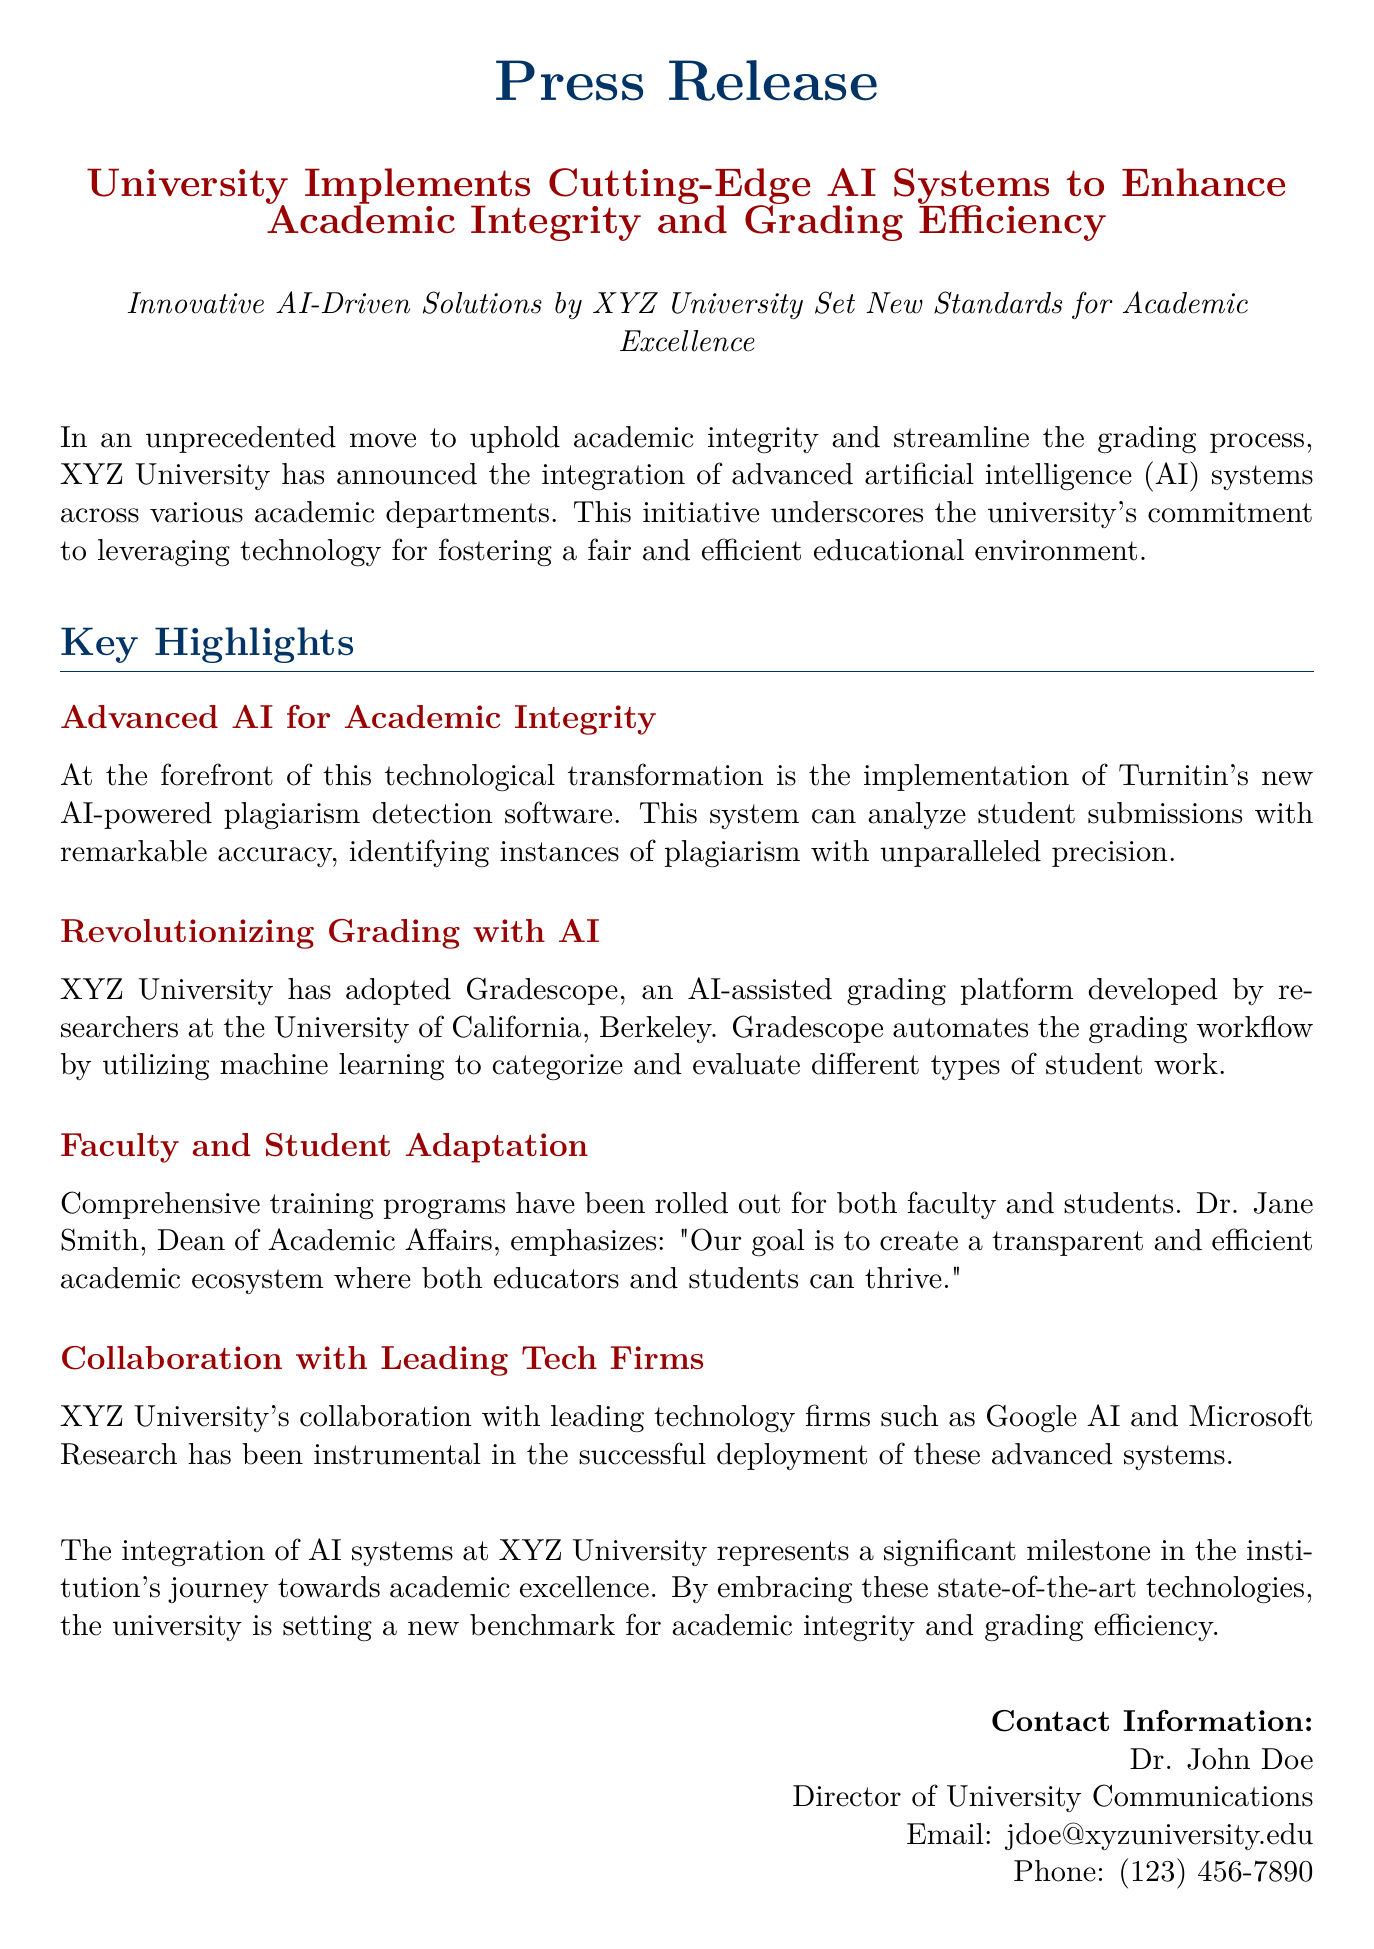What AI-powered software is used for plagiarism detection? The document mentions that XYZ University has implemented Turnitin's new AI-powered plagiarism detection software for this purpose.
Answer: Turnitin What grading platform has been adopted by XYZ University? Gradescope, an AI-assisted grading platform developed by researchers at the University of California, Berkeley, has been adopted for grading.
Answer: Gradescope Who is the Dean of Academic Affairs? The document states that Dr. Jane Smith is the Dean of Academic Affairs, who emphasizes the goal of transparent and efficient academic ecosystems.
Answer: Dr. Jane Smith Which technology firms collaborated with XYZ University for this initiative? The press release indicates that leading technology firms such as Google AI and Microsoft Research collaborated with the university for successful deployment.
Answer: Google AI and Microsoft Research What is the main goal of integrating advanced AI systems at XYZ University? The primary aim of this integration is to uphold academic integrity and streamline the grading process, as expressed in the document.
Answer: Uphold academic integrity and streamline grading process How many technology firms are mentioned in the press release? The document identifies two technology firms specifically involved in the collaboration: Google AI and Microsoft Research, which implies a total of two.
Answer: Two What is the contact email for the Director of University Communications? The document provides the email address for Dr. John Doe, the Director of University Communications, to be jdoe@xyzuniversity.edu.
Answer: jdoe@xyzuniversity.edu Which academic departments are expected to implement the AI systems? The press release does not specify particular departments but indicates that the integration will occur across various academic departments.
Answer: Various academic departments 